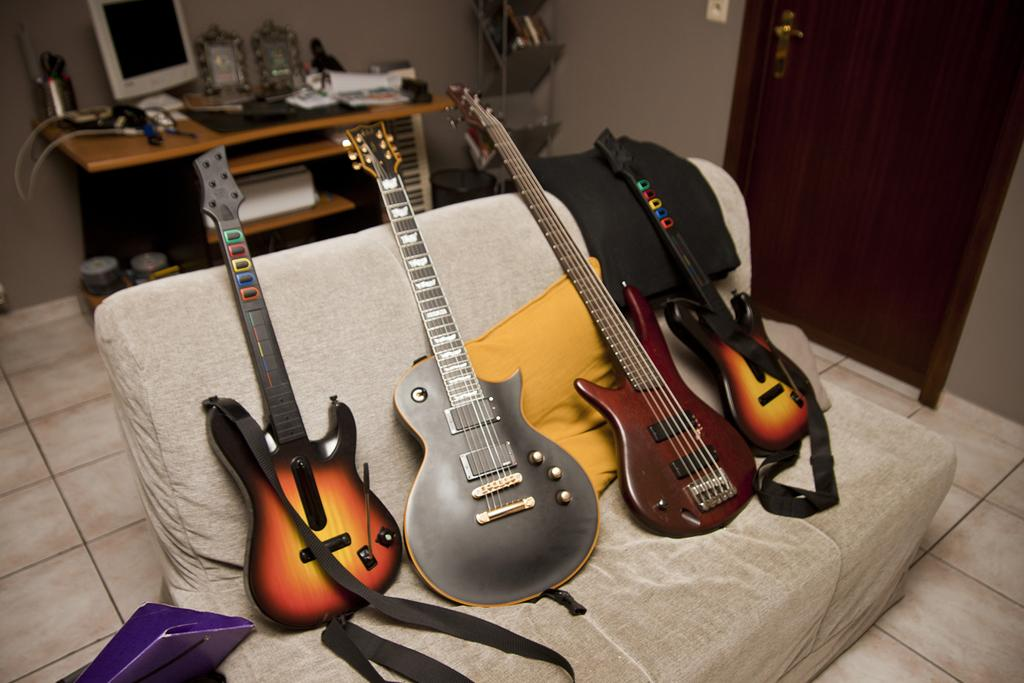How many guitars are in the image? There are four different guitars in the image. Where are the guitars placed? The guitars are placed on a couch. What can be seen in the background of the image? There is a table in the background of the image. What is on the table? A system and books are present on the table. Is there any entrance visible in the image? Yes, there is a door visible in the image. What type of insurance policy is being discussed in the image? There is no discussion of insurance in the image; it features four guitars placed on a couch, a table with a system and books, and a door. 